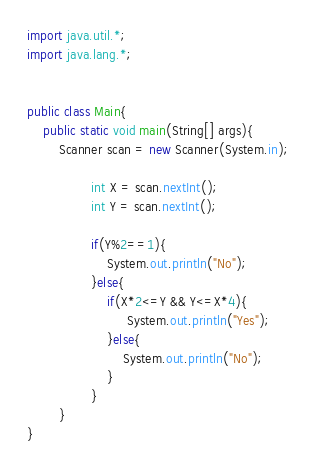<code> <loc_0><loc_0><loc_500><loc_500><_Java_>import java.util.*; 
import java.lang.*; 


public class Main{
	public static void main(String[] args){
		Scanner scan = new Scanner(System.in);
                
                int X = scan.nextInt();
                int Y = scan.nextInt();
                
                if(Y%2==1){
                    System.out.println("No");
                }else{
                    if(X*2<=Y && Y<=X*4){
                         System.out.println("Yes");
                    }else{
                        System.out.println("No");
                    }
                }
        }
}</code> 